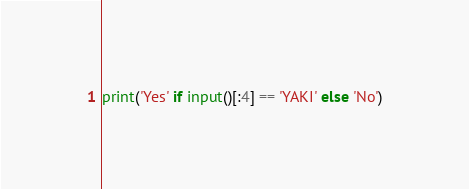Convert code to text. <code><loc_0><loc_0><loc_500><loc_500><_Python_>print('Yes' if input()[:4] == 'YAKI' else 'No')</code> 